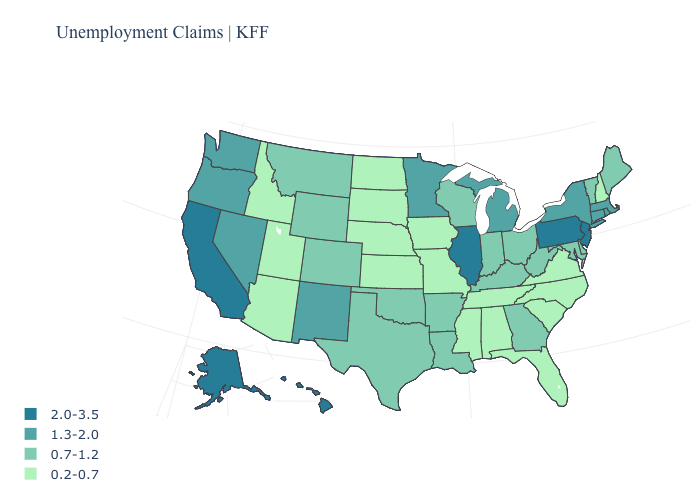Is the legend a continuous bar?
Be succinct. No. Among the states that border Washington , does Idaho have the lowest value?
Write a very short answer. Yes. What is the value of Wyoming?
Be succinct. 0.7-1.2. Name the states that have a value in the range 0.2-0.7?
Answer briefly. Alabama, Arizona, Florida, Idaho, Iowa, Kansas, Mississippi, Missouri, Nebraska, New Hampshire, North Carolina, North Dakota, South Carolina, South Dakota, Tennessee, Utah, Virginia. Name the states that have a value in the range 1.3-2.0?
Give a very brief answer. Connecticut, Massachusetts, Michigan, Minnesota, Nevada, New Mexico, New York, Oregon, Rhode Island, Washington. Which states have the lowest value in the Northeast?
Give a very brief answer. New Hampshire. Does Utah have the highest value in the USA?
Give a very brief answer. No. Name the states that have a value in the range 2.0-3.5?
Be succinct. Alaska, California, Hawaii, Illinois, New Jersey, Pennsylvania. Among the states that border New Jersey , which have the highest value?
Give a very brief answer. Pennsylvania. Does the first symbol in the legend represent the smallest category?
Answer briefly. No. Among the states that border Vermont , which have the highest value?
Concise answer only. Massachusetts, New York. Name the states that have a value in the range 0.7-1.2?
Short answer required. Arkansas, Colorado, Delaware, Georgia, Indiana, Kentucky, Louisiana, Maine, Maryland, Montana, Ohio, Oklahoma, Texas, Vermont, West Virginia, Wisconsin, Wyoming. Name the states that have a value in the range 0.2-0.7?
Give a very brief answer. Alabama, Arizona, Florida, Idaho, Iowa, Kansas, Mississippi, Missouri, Nebraska, New Hampshire, North Carolina, North Dakota, South Carolina, South Dakota, Tennessee, Utah, Virginia. What is the highest value in the USA?
Quick response, please. 2.0-3.5. Does the map have missing data?
Concise answer only. No. 